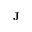Convert formula to latex. <formula><loc_0><loc_0><loc_500><loc_500>J</formula> 